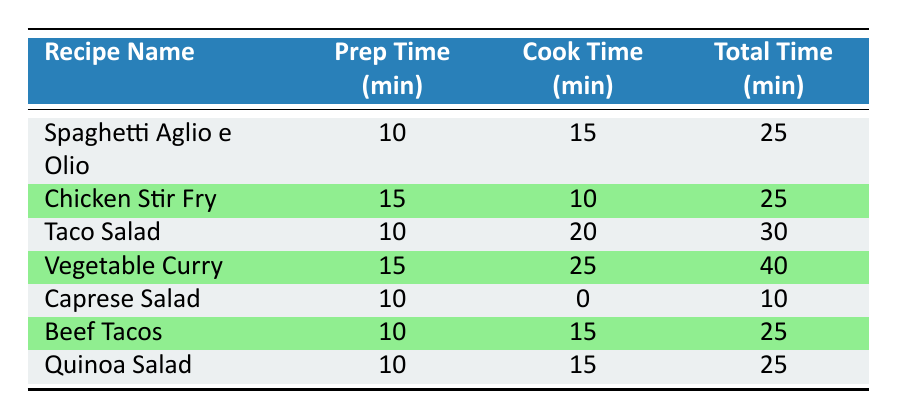What is the total time required for making Taco Salad? According to the table, the total time for Taco Salad is directly provided in the respective row. It shows that the total time is 30 minutes.
Answer: 30 minutes Which recipe has the shortest total time? By examining the total time column in the table, it is clear that Caprese Salad has the shortest total time at 10 minutes, compared to the other recipes.
Answer: Caprese Salad What is the average preparation time for all recipes? The total preparation times for all recipes are 10, 15, 10, 15, 10, 10, and 10 minutes respectively. Adding these gives a total of 80 minutes. There are 7 recipes, so the average is 80/7 which is approximately 11.43 minutes.
Answer: 11.43 minutes Does Chicken Stir Fry have a shorter cook time than Vegetable Curry? The cook time for Chicken Stir Fry is 10 minutes while for Vegetable Curry it is 25 minutes. Since 10 is less than 25, the statement is true.
Answer: Yes What is the total cooking time for the three recipes with the highest cook times? The recipes with the highest cook times are Vegetable Curry (25 minutes), Taco Salad (20 minutes), and Chicken Stir Fry (10 minutes). Adding these values gives: 25 + 20 + 10 = 55 minutes for total cooking time.
Answer: 55 minutes 